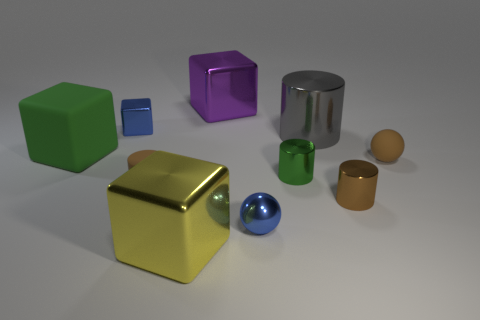What is the material of the thing that is the same color as the small metallic ball?
Make the answer very short. Metal. Are there any tiny metallic cubes of the same color as the small metallic sphere?
Provide a short and direct response. Yes. Is the small metallic cube the same color as the small metallic ball?
Keep it short and to the point. Yes. There is a big thing that is in front of the brown metallic thing; does it have the same color as the shiny ball?
Make the answer very short. No. Does the shiny ball have the same color as the tiny metal object that is behind the tiny green metallic cylinder?
Offer a terse response. Yes. There is a purple thing that is the same material as the big yellow block; what is its shape?
Your answer should be very brief. Cube. Is there anything else that has the same color as the big rubber thing?
Give a very brief answer. Yes. Is the number of small blue objects that are in front of the tiny blue block greater than the number of small yellow things?
Offer a terse response. Yes. There is a purple thing; is its shape the same as the brown matte object left of the small green metallic object?
Give a very brief answer. No. How many metallic blocks have the same size as the blue ball?
Offer a very short reply. 1. 